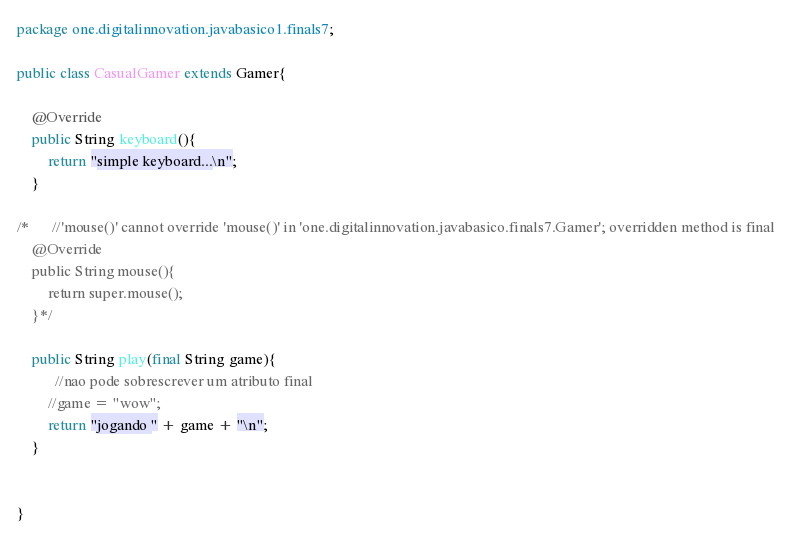<code> <loc_0><loc_0><loc_500><loc_500><_Java_>package one.digitalinnovation.javabasico1.finals7;

public class CasualGamer extends Gamer{

    @Override
    public String keyboard(){
        return "simple keyboard...\n";
    }

/*      //'mouse()' cannot override 'mouse()' in 'one.digitalinnovation.javabasico.finals7.Gamer'; overridden method is final
    @Override
    public String mouse(){
        return super.mouse();
    }*/

    public String play(final String game){
          //nao pode sobrescrever um atributo final
        //game = "wow";
        return "jogando " + game + "\n";
    }


}
</code> 